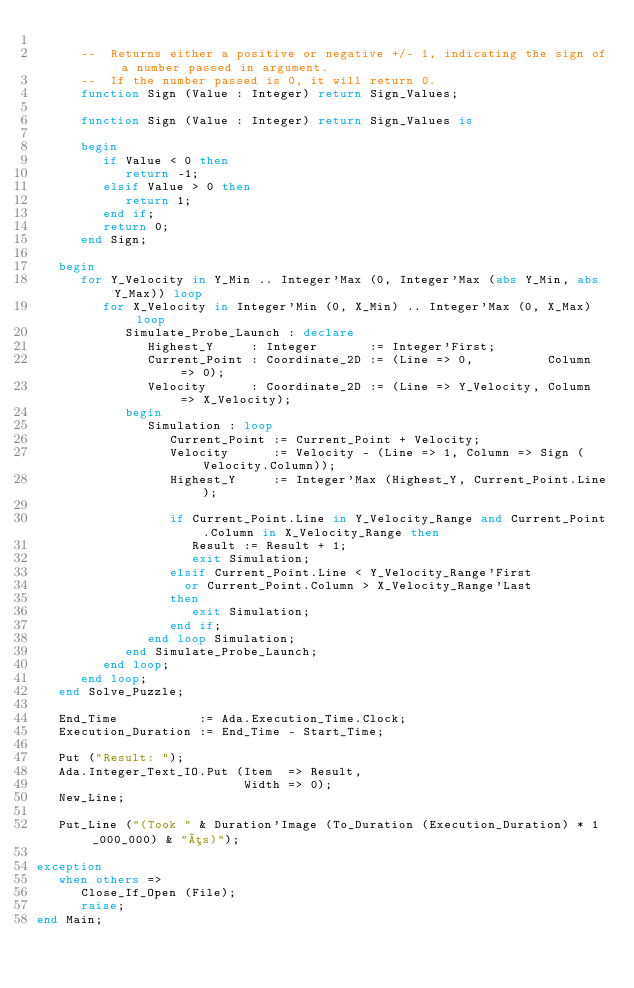<code> <loc_0><loc_0><loc_500><loc_500><_Ada_>
      --  Returns either a positive or negative +/- 1, indicating the sign of a number passed in argument.
      --  If the number passed is 0, it will return 0.
      function Sign (Value : Integer) return Sign_Values;

      function Sign (Value : Integer) return Sign_Values is

      begin
         if Value < 0 then
            return -1;
         elsif Value > 0 then
            return 1;
         end if;
         return 0;
      end Sign;

   begin
      for Y_Velocity in Y_Min .. Integer'Max (0, Integer'Max (abs Y_Min, abs Y_Max)) loop
         for X_Velocity in Integer'Min (0, X_Min) .. Integer'Max (0, X_Max) loop
            Simulate_Probe_Launch : declare
               Highest_Y     : Integer       := Integer'First;
               Current_Point : Coordinate_2D := (Line => 0,          Column => 0);
               Velocity      : Coordinate_2D := (Line => Y_Velocity, Column => X_Velocity);
            begin
               Simulation : loop
                  Current_Point := Current_Point + Velocity;
                  Velocity      := Velocity - (Line => 1, Column => Sign (Velocity.Column));
                  Highest_Y     := Integer'Max (Highest_Y, Current_Point.Line);

                  if Current_Point.Line in Y_Velocity_Range and Current_Point.Column in X_Velocity_Range then
                     Result := Result + 1;
                     exit Simulation;
                  elsif Current_Point.Line < Y_Velocity_Range'First
                    or Current_Point.Column > X_Velocity_Range'Last
                  then
                     exit Simulation;
                  end if;
               end loop Simulation;
            end Simulate_Probe_Launch;
         end loop;
      end loop;
   end Solve_Puzzle;

   End_Time           := Ada.Execution_Time.Clock;
   Execution_Duration := End_Time - Start_Time;

   Put ("Result: ");
   Ada.Integer_Text_IO.Put (Item  => Result,
                            Width => 0);
   New_Line;

   Put_Line ("(Took " & Duration'Image (To_Duration (Execution_Duration) * 1_000_000) & "µs)");

exception
   when others =>
      Close_If_Open (File);
      raise;
end Main;
</code> 